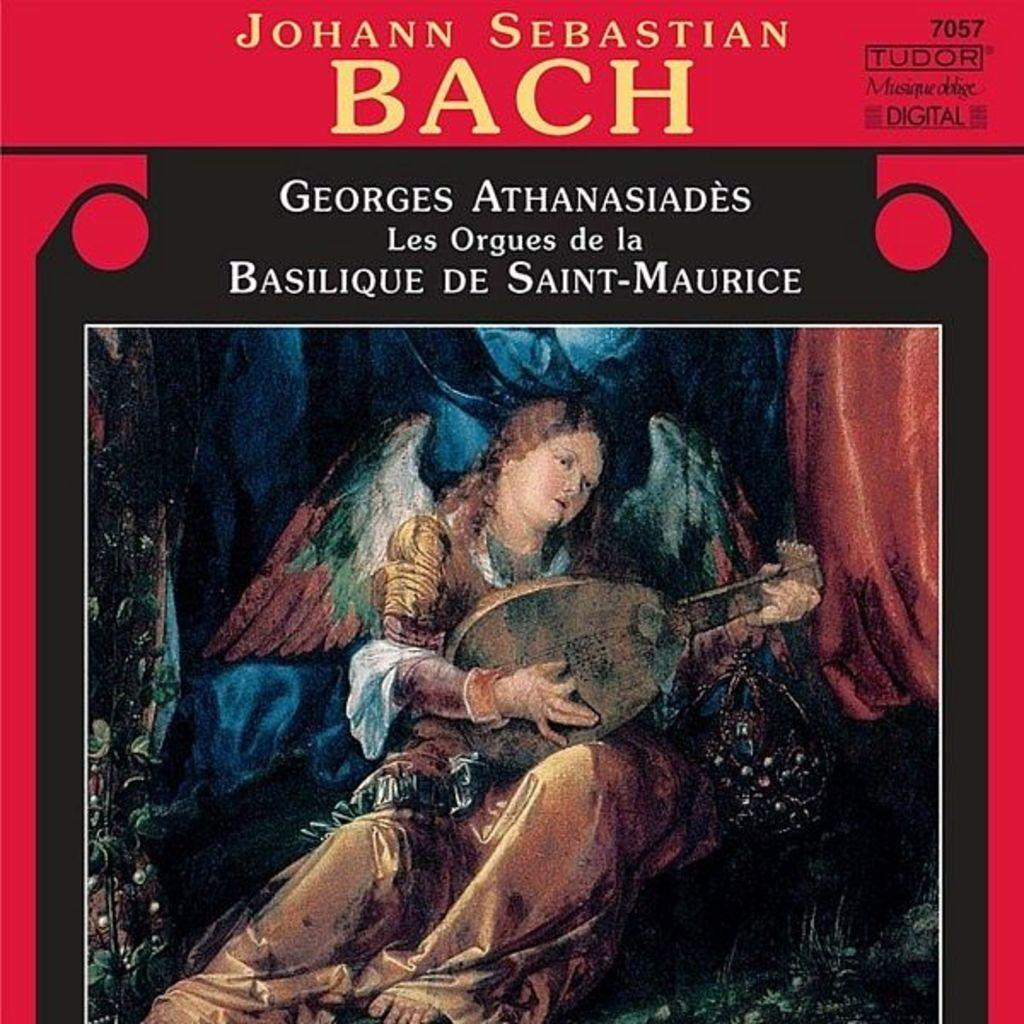Provide a one-sentence caption for the provided image. Artwork for a piece of music by Johann Sebastian Bach. 